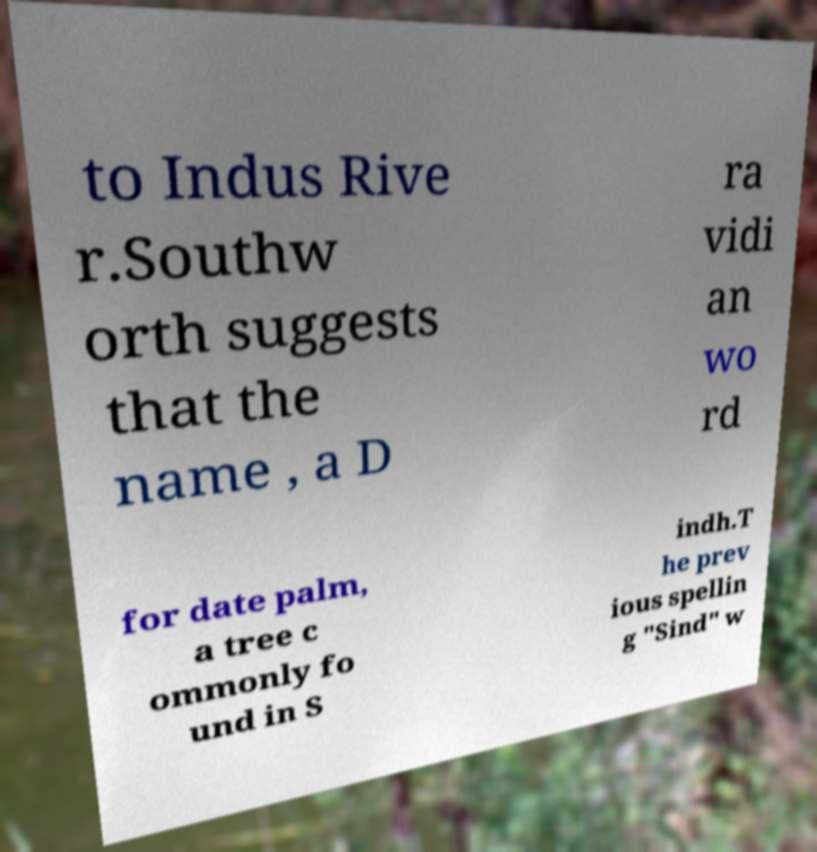Can you accurately transcribe the text from the provided image for me? to Indus Rive r.Southw orth suggests that the name , a D ra vidi an wo rd for date palm, a tree c ommonly fo und in S indh.T he prev ious spellin g "Sind" w 